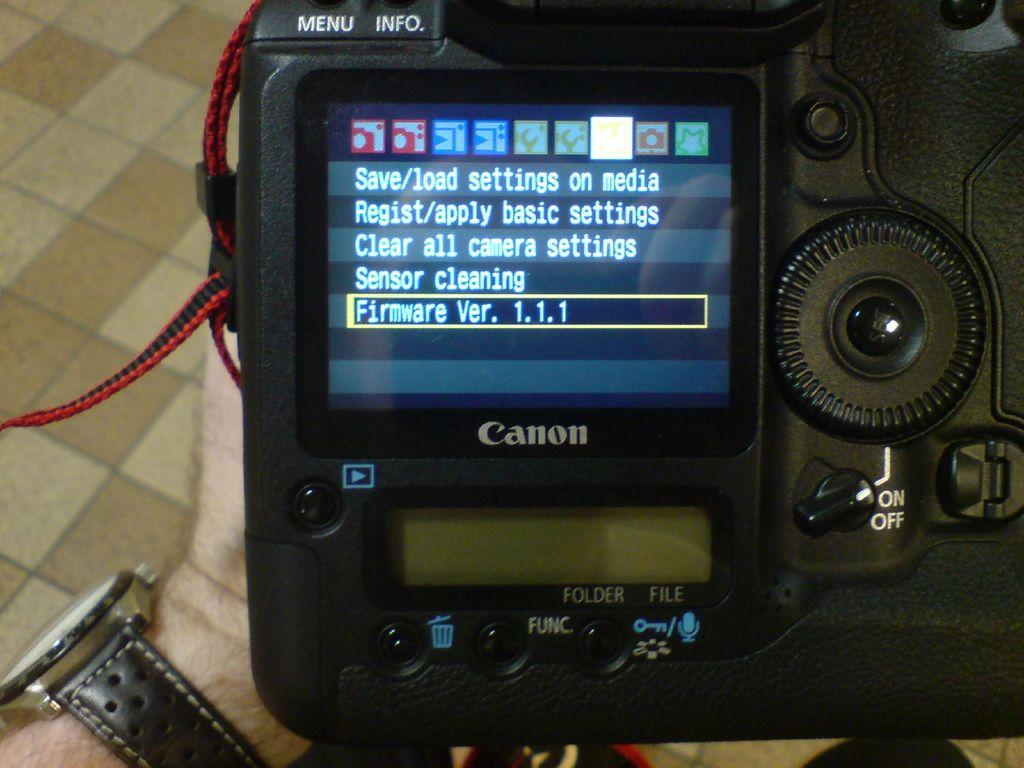<image>
Render a clear and concise summary of the photo. A man holding a camera revealing that it is using firmware version 1.1.1. 